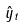Convert formula to latex. <formula><loc_0><loc_0><loc_500><loc_500>\hat { y } _ { t }</formula> 